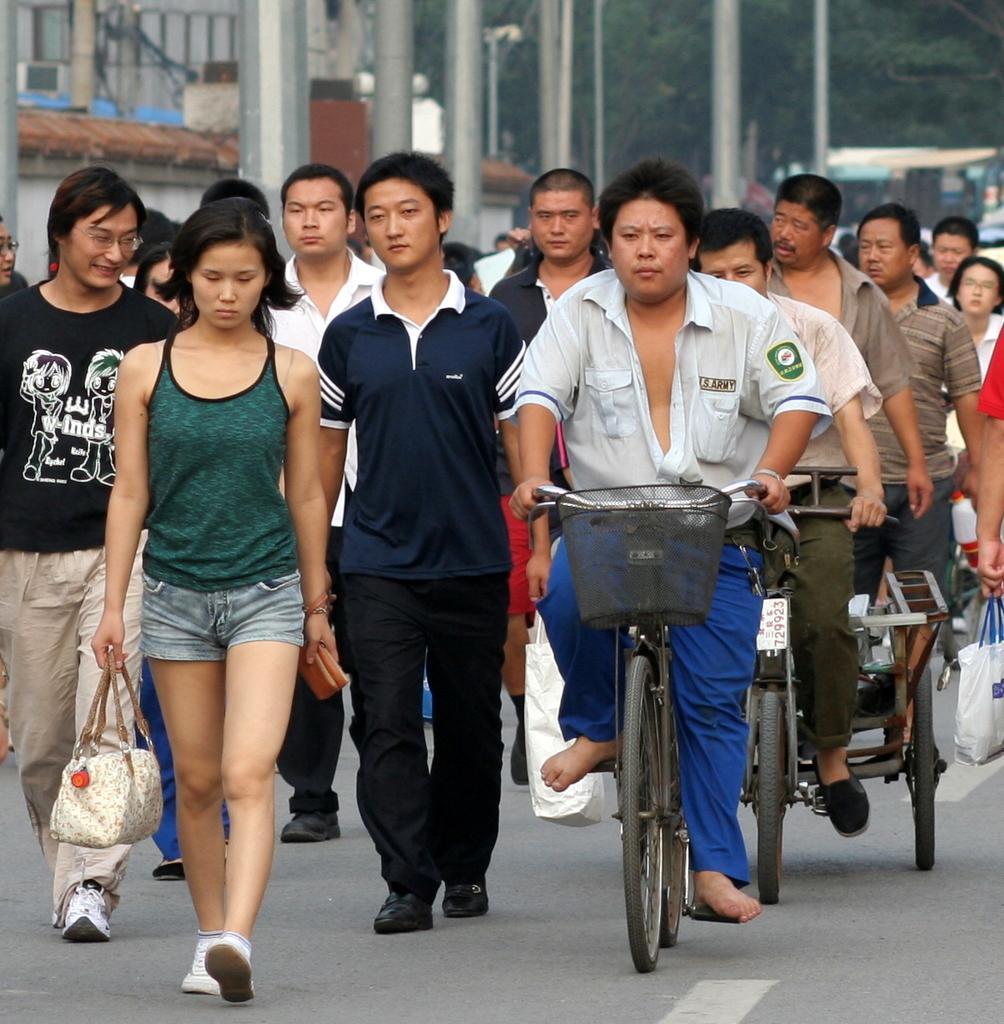Describe this image in one or two sentences. Hear, this picture is clicked outside the city. There are many people walking on the road. Man in white shirt and blue pant is riding bicycle. Behind him, the man in white shirt and green pant is riding rickshaw. Woman in green t-shirt is holding hand bag in her hands and behind these people, we see pillars and behind this pillars, we see trees. 